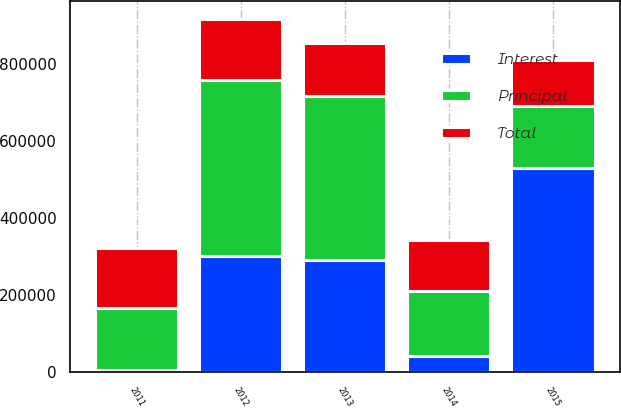<chart> <loc_0><loc_0><loc_500><loc_500><stacked_bar_chart><ecel><fcel>2011<fcel>2012<fcel>2013<fcel>2014<fcel>2015<nl><fcel>Principal<fcel>161622<fcel>459551<fcel>427529<fcel>170904<fcel>160486<nl><fcel>Interest<fcel>5246<fcel>300202<fcel>290166<fcel>40177<fcel>530145<nl><fcel>Total<fcel>156376<fcel>159349<fcel>137363<fcel>130727<fcel>120413<nl></chart> 